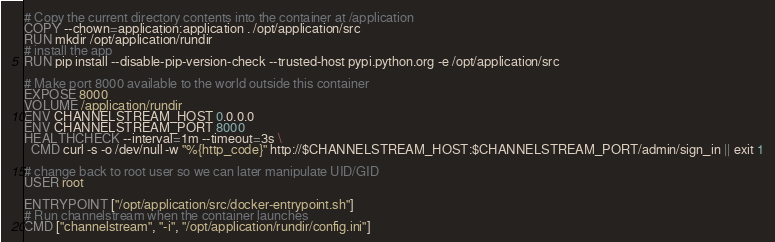<code> <loc_0><loc_0><loc_500><loc_500><_Dockerfile_># Copy the current directory contents into the container at /application
COPY --chown=application:application . /opt/application/src
RUN mkdir /opt/application/rundir
# install the app
RUN pip install --disable-pip-version-check --trusted-host pypi.python.org -e /opt/application/src

# Make port 8000 available to the world outside this container
EXPOSE 8000
VOLUME /application/rundir
ENV CHANNELSTREAM_HOST 0.0.0.0
ENV CHANNELSTREAM_PORT 8000
HEALTHCHECK --interval=1m --timeout=3s \
  CMD curl -s -o /dev/null -w "%{http_code}" http://$CHANNELSTREAM_HOST:$CHANNELSTREAM_PORT/admin/sign_in || exit 1

# change back to root user so we can later manipulate UID/GID
USER root

ENTRYPOINT ["/opt/application/src/docker-entrypoint.sh"]
# Run channelstream when the container launches
CMD ["channelstream", "-i", "/opt/application/rundir/config.ini"]
</code> 